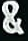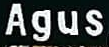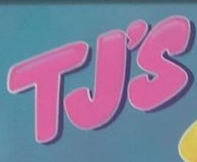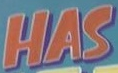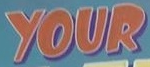What text is displayed in these images sequentially, separated by a semicolon? &; Agus; TJ'S; HAS; YOUR 